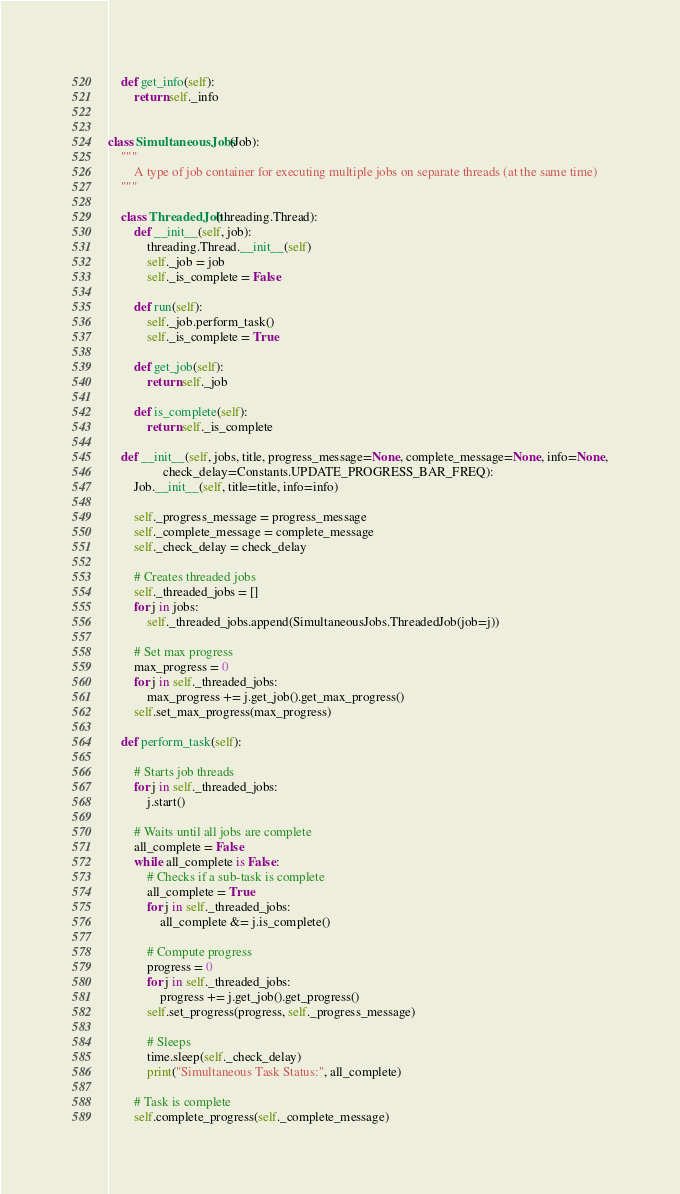Convert code to text. <code><loc_0><loc_0><loc_500><loc_500><_Python_>    def get_info(self):
        return self._info


class SimultaneousJobs(Job):
    """
        A type of job container for executing multiple jobs on separate threads (at the same time)
    """

    class ThreadedJob(threading.Thread):
        def __init__(self, job):
            threading.Thread.__init__(self)
            self._job = job
            self._is_complete = False

        def run(self):
            self._job.perform_task()
            self._is_complete = True

        def get_job(self):
            return self._job

        def is_complete(self):
            return self._is_complete

    def __init__(self, jobs, title, progress_message=None, complete_message=None, info=None,
                 check_delay=Constants.UPDATE_PROGRESS_BAR_FREQ):
        Job.__init__(self, title=title, info=info)

        self._progress_message = progress_message
        self._complete_message = complete_message
        self._check_delay = check_delay

        # Creates threaded jobs
        self._threaded_jobs = []
        for j in jobs:
            self._threaded_jobs.append(SimultaneousJobs.ThreadedJob(job=j))

        # Set max progress
        max_progress = 0
        for j in self._threaded_jobs:
            max_progress += j.get_job().get_max_progress()
        self.set_max_progress(max_progress)

    def perform_task(self):

        # Starts job threads
        for j in self._threaded_jobs:
            j.start()

        # Waits until all jobs are complete
        all_complete = False
        while all_complete is False:
            # Checks if a sub-task is complete
            all_complete = True
            for j in self._threaded_jobs:
                all_complete &= j.is_complete()

            # Compute progress
            progress = 0
            for j in self._threaded_jobs:
                progress += j.get_job().get_progress()
            self.set_progress(progress, self._progress_message)

            # Sleeps
            time.sleep(self._check_delay)
            print("Simultaneous Task Status:", all_complete)

        # Task is complete
        self.complete_progress(self._complete_message)
</code> 